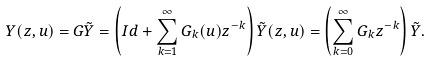<formula> <loc_0><loc_0><loc_500><loc_500>Y ( z , u ) = G \tilde { Y } = \left ( I d + \sum _ { k = 1 } ^ { \infty } G _ { k } ( u ) z ^ { - k } \right ) \tilde { Y } ( z , u ) = \left ( \sum _ { k = 0 } ^ { \infty } G _ { k } z ^ { - k } \right ) \tilde { Y } .</formula> 